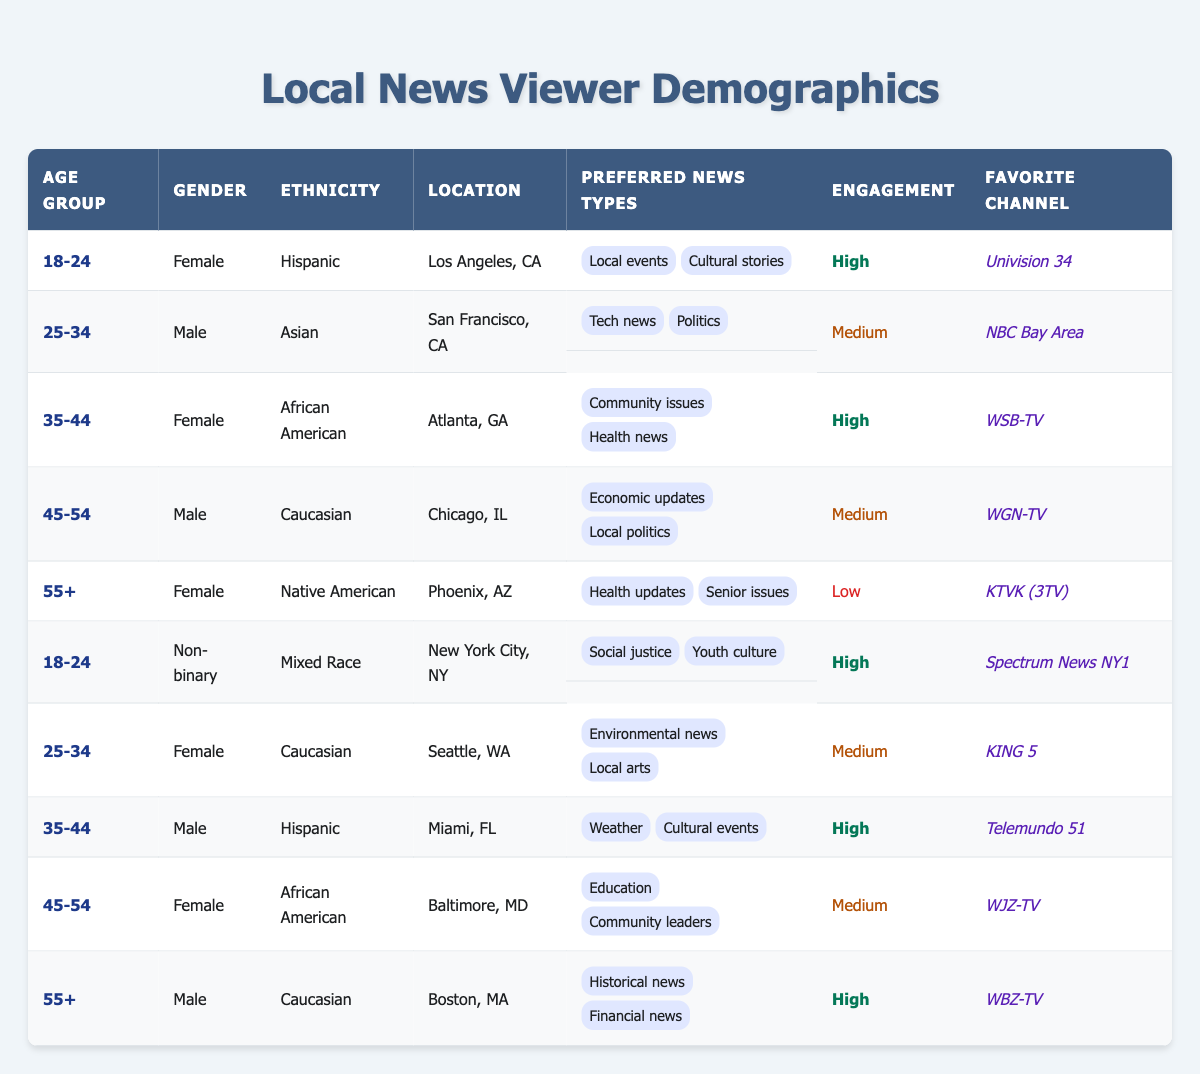What is the favorite news channel for the 18-24 age group? The table shows that there are two entries for the 18-24 age group. The first entry lists "Univision 34" as the favorite channel for a Hispanic female in Los Angeles, while the second entry lists "Spectrum News NY1" as the favorite for a non-binary mixed race individual in New York City. There are different favorite channels for this age group, so we can state that both are favorites among this demographic.
Answer: Univision 34 and Spectrum News NY1 Which age group has the highest engagement level? The table indicates two age groups, 18-24 and 35-44, that both have high engagement levels. Three individuals are listed within those age groups with a high engagement level: a Hispanic female in Los Angeles, a non-binary mixed race individual in New York City, and a Hispanic male in Miami. Thus, both the 18-24 and 35-44 age groups can be considered as having the highest engagement level.
Answer: 18-24 and 35-44 How many viewers between the ages of 45-54 prefer community issues as their news type? The table shows two viewers in the 45-54 age group. However, neither of them lists "community issues" as their preferred news type. The first viewer prefers economic updates and local politics, while the second prefers education and community leaders. Therefore, there are no viewers in this age group who prefer community issues.
Answer: 0 Is there a viewer who prefers environmental news and also belongs to the female gender? According to the table, environmental news is cited as the preferred news type by a Caucasian female from Seattle, WA in the 25-34 age group. Thus, there is indeed a viewer fitting both criteria of preferring environmental news and being female.
Answer: Yes What is the total number of viewers from diverse ethnicities who prefer health news? In the table, there are two viewers who prefer health news: a female from Atlanta who highlights community issues and health news, and a female from Phoenix focusing on health updates and senior issues. Both of these individuals identify with different ethnicities (African American and Native American, respectively). Therefore, summing them gives us a total of two viewers.
Answer: 2 Are there more male viewers than female viewers in the 55+ age group? The table indicates two viewers in the 55+ age group: one male (Caucasian from Boston) and one female (Native American from Phoenix). Since there’s an equal number of male and female viewers (one each), we can't say that there are more male viewers than female viewers.
Answer: No Which preferred news type appears among the viewers in the 35-44 age group? The 35-44 age group has two viewers. One (female, African American from Atlanta) prefers community issues and health news, while the other (male, Hispanic from Miami) prefers weather and cultural events. The common news type that crosses both of their interests is cultural events, specifically indicated by the male viewer. No other news types overlap, so cultural events is the shared preferred type for the 35-44 age group.
Answer: Cultural events What percentage of viewers prefer local arts as their news type? The table indicates that out of a total of 10 viewers, only one viewer from the 25-34 age group (Caucasian female in Seattle) prefers local arts as a news type. To calculate the percentage, divide the number of viewers preferring local arts (1) by the total number of viewers (10) and then multiply by 100. Thus, (1/10) * 100 = 10%.
Answer: 10% 